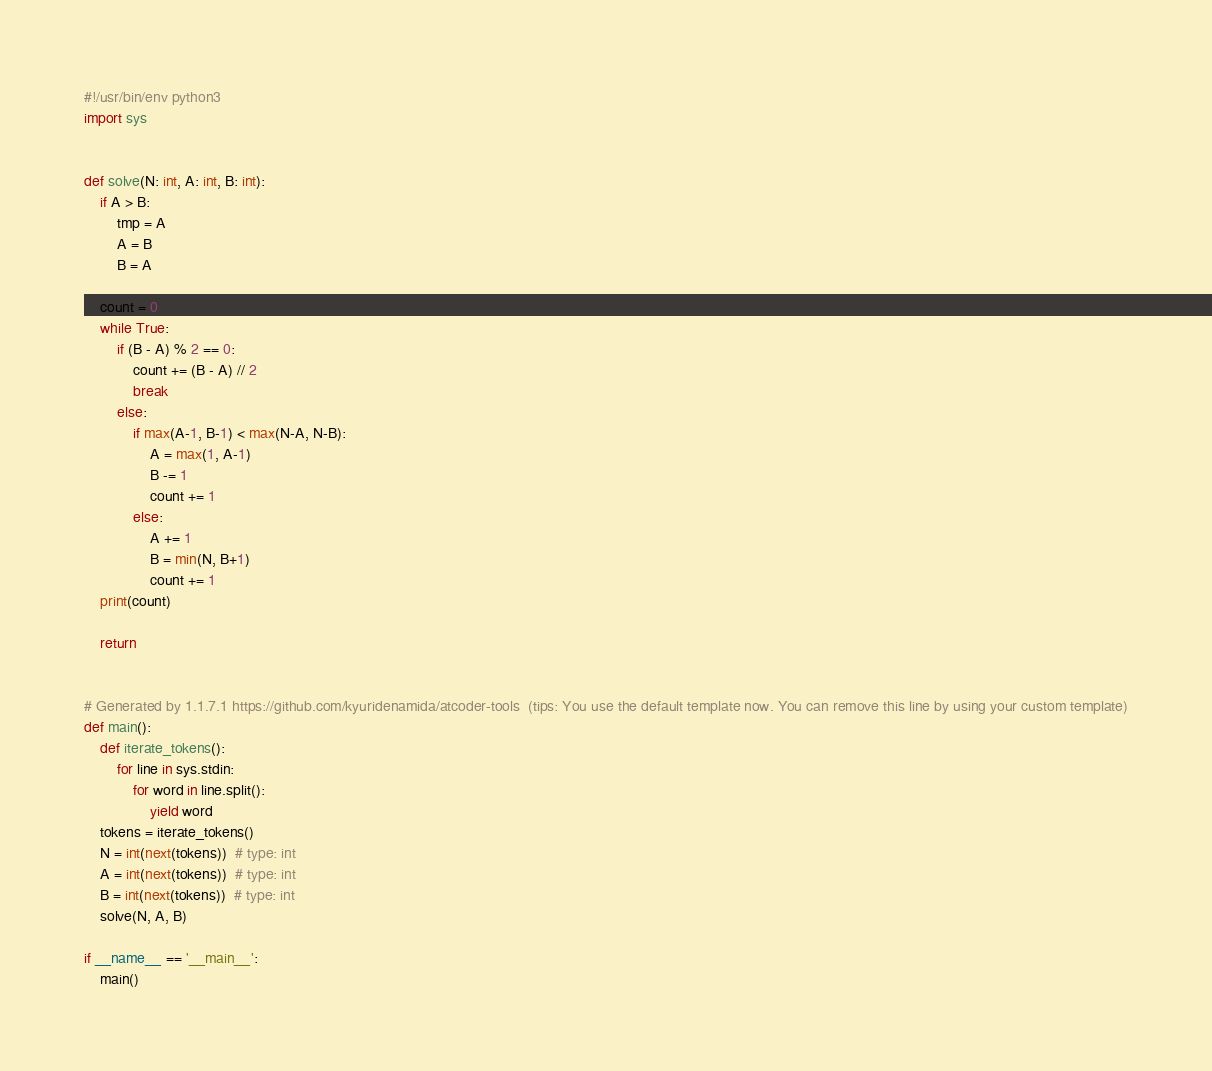Convert code to text. <code><loc_0><loc_0><loc_500><loc_500><_Python_>#!/usr/bin/env python3
import sys


def solve(N: int, A: int, B: int):
    if A > B:
        tmp = A
        A = B
        B = A
    
    count = 0
    while True:
        if (B - A) % 2 == 0:
            count += (B - A) // 2
            break
        else:
            if max(A-1, B-1) < max(N-A, N-B):
                A = max(1, A-1)
                B -= 1
                count += 1
            else:
                A += 1
                B = min(N, B+1)
                count += 1
    print(count)

    return


# Generated by 1.1.7.1 https://github.com/kyuridenamida/atcoder-tools  (tips: You use the default template now. You can remove this line by using your custom template)
def main():
    def iterate_tokens():
        for line in sys.stdin:
            for word in line.split():
                yield word
    tokens = iterate_tokens()
    N = int(next(tokens))  # type: int
    A = int(next(tokens))  # type: int
    B = int(next(tokens))  # type: int
    solve(N, A, B)

if __name__ == '__main__':
    main()
</code> 